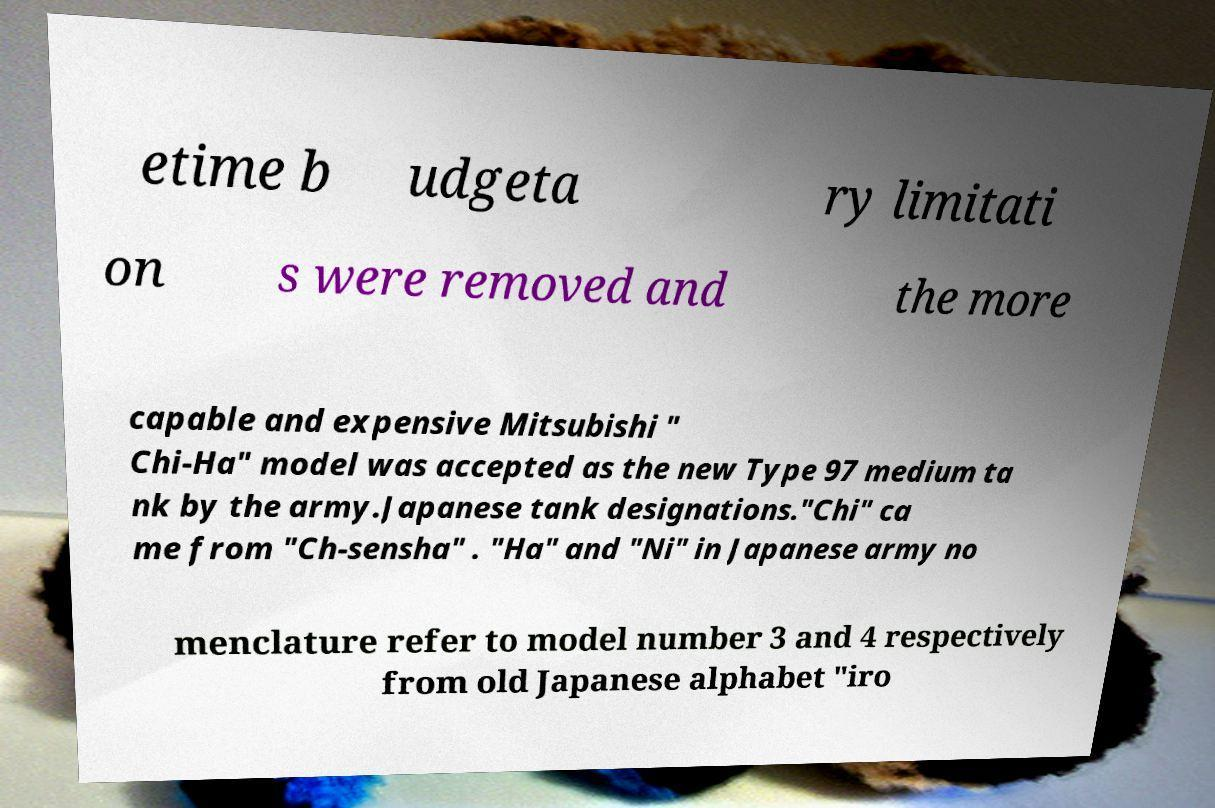Could you extract and type out the text from this image? etime b udgeta ry limitati on s were removed and the more capable and expensive Mitsubishi " Chi-Ha" model was accepted as the new Type 97 medium ta nk by the army.Japanese tank designations."Chi" ca me from "Ch-sensha" . "Ha" and "Ni" in Japanese army no menclature refer to model number 3 and 4 respectively from old Japanese alphabet "iro 